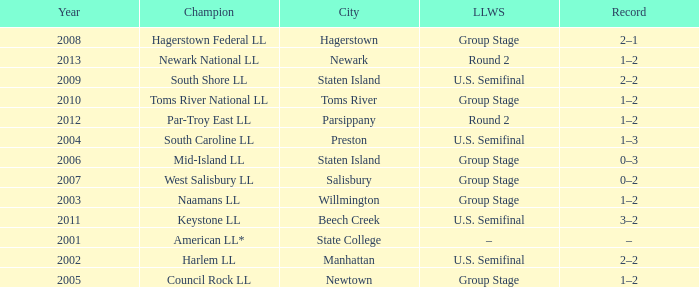Which Little League World Series took place in Parsippany? Round 2. 